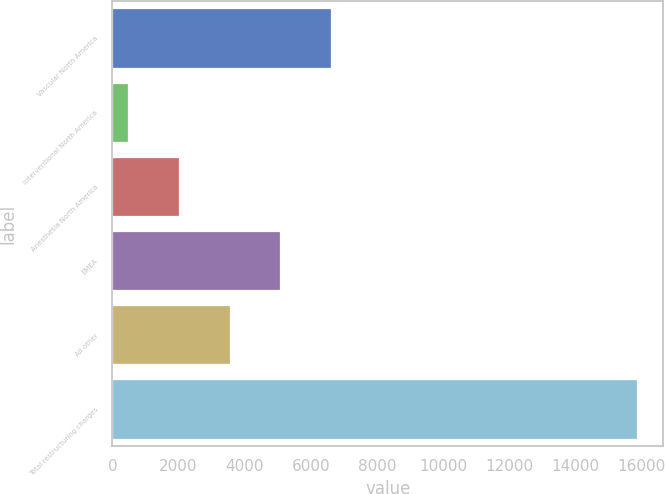<chart> <loc_0><loc_0><loc_500><loc_500><bar_chart><fcel>Vascular North America<fcel>Interventional North America<fcel>Anesthesia North America<fcel>EMEA<fcel>All other<fcel>Total restructuring charges<nl><fcel>6623.8<fcel>459<fcel>2000.2<fcel>5082.6<fcel>3541.4<fcel>15871<nl></chart> 